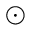<formula> <loc_0><loc_0><loc_500><loc_500>\odot</formula> 